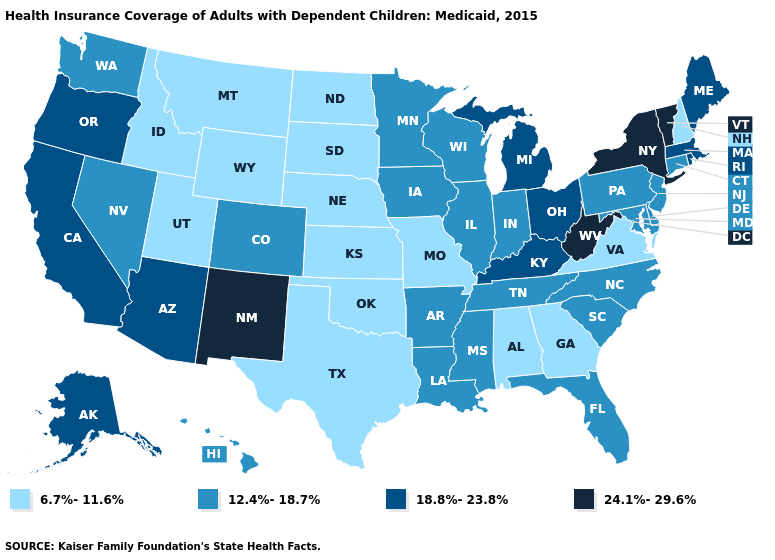What is the value of Massachusetts?
Short answer required. 18.8%-23.8%. What is the highest value in states that border Texas?
Short answer required. 24.1%-29.6%. Name the states that have a value in the range 18.8%-23.8%?
Concise answer only. Alaska, Arizona, California, Kentucky, Maine, Massachusetts, Michigan, Ohio, Oregon, Rhode Island. What is the value of South Dakota?
Answer briefly. 6.7%-11.6%. Does Arkansas have the highest value in the South?
Be succinct. No. What is the highest value in the USA?
Write a very short answer. 24.1%-29.6%. Does Oregon have the lowest value in the USA?
Quick response, please. No. Among the states that border New Jersey , does New York have the highest value?
Concise answer only. Yes. Name the states that have a value in the range 18.8%-23.8%?
Keep it brief. Alaska, Arizona, California, Kentucky, Maine, Massachusetts, Michigan, Ohio, Oregon, Rhode Island. What is the value of Arizona?
Write a very short answer. 18.8%-23.8%. Which states have the lowest value in the Northeast?
Keep it brief. New Hampshire. Does Nebraska have the highest value in the MidWest?
Be succinct. No. What is the value of Montana?
Be succinct. 6.7%-11.6%. Name the states that have a value in the range 6.7%-11.6%?
Concise answer only. Alabama, Georgia, Idaho, Kansas, Missouri, Montana, Nebraska, New Hampshire, North Dakota, Oklahoma, South Dakota, Texas, Utah, Virginia, Wyoming. What is the value of Texas?
Quick response, please. 6.7%-11.6%. 